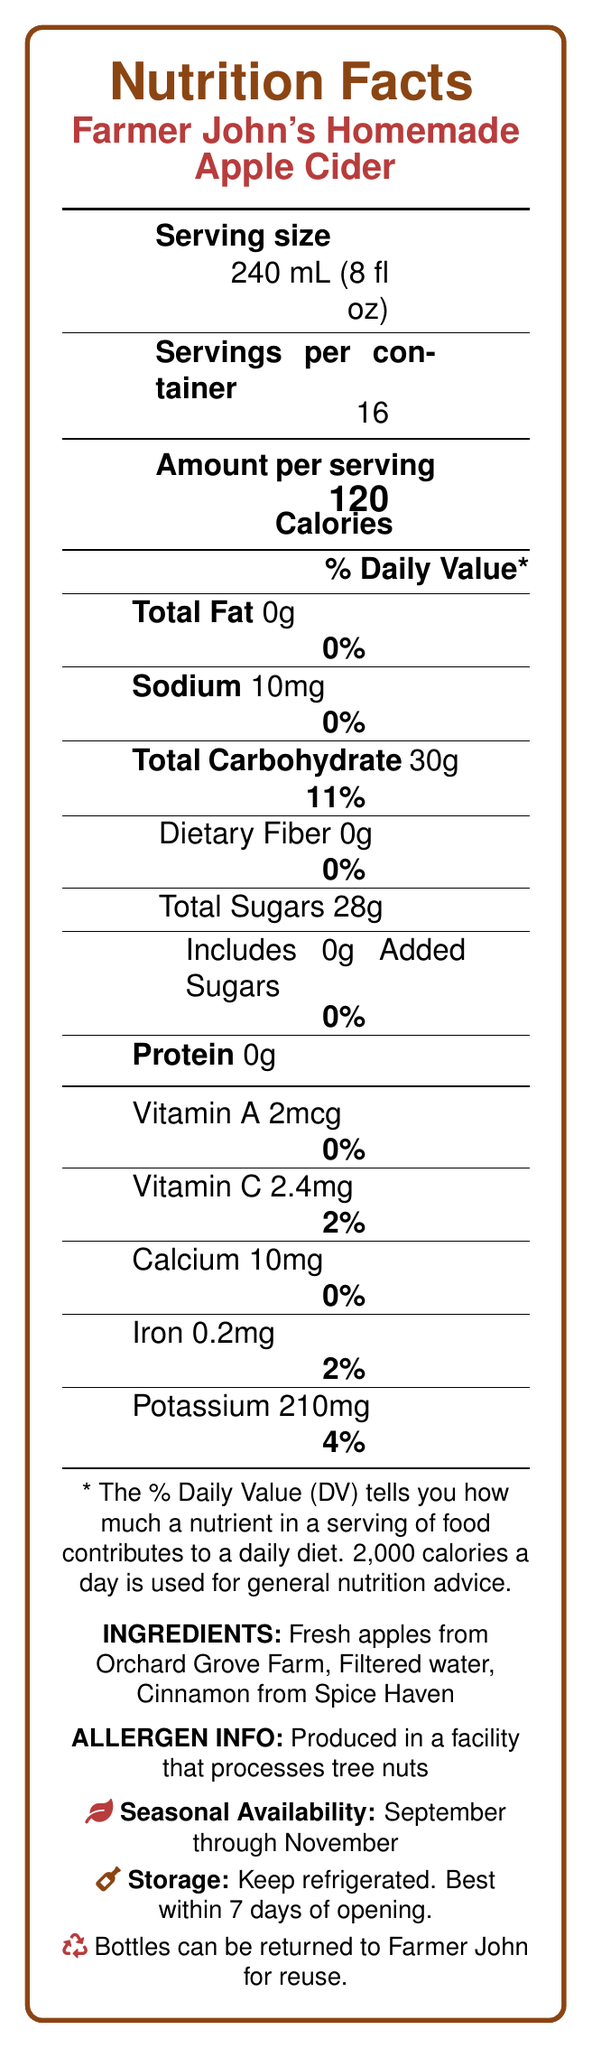What is the serving size for Farmer John's Homemade Apple Cider? The serving size is listed at the beginning of the document in the Nutrition Facts section.
Answer: 240 mL (8 fl oz) How many calories are in one serving of the apple cider? The document specifies that each serving contains 120 calories.
Answer: 120 calories How many grams of total sugars are in one serving? The total sugars per serving are specified as 28g in the Nutrition Facts section.
Answer: 28g Are there any added sugars in Farmer John’s Homemade Apple Cider? The document states that the apple cider includes 0g of added sugars.
Answer: No What is the ingredient list for Farmer John's Homemade Apple Cider? The ingredients are listed at the bottom of the Nutrition Facts.
Answer: Fresh apples from Orchard Grove Farm, Filtered water, Cinnamon from Spice Haven What are some of the serving suggestions provided for the apple cider? These suggestions are found in the "eventPlannerNotes" section.
Answer: Serve chilled in Mason jars, Garnish with a cinnamon stick, Offer as a welcome drink at autumn weddings What percentage of the daily value does the sodium content in one serving represent? The sodium content per serving is listed as 10mg, which is 0% of the daily value.
Answer: 0% Farmer John's Homemade Apple Cider is made from which apple varieties? A. Granny Smith, Golden Delicious, Fuji B. Honeycrisp, Gala, Fuji C. Red Delicious, Honeycrisp, Gala The document indicates that the apple cider is made from Honeycrisp, Gala, and Fuji apple varieties.
Answer: B What is the seasonal availability of Farmer John's Homemade Apple Cider? A. June through August B. September through November C. December through February D. March through May The cider is available from September through November, as stated in the seasonal availability section.
Answer: B Does the cider contain any dietary fiber? The document lists 0g of dietary fiber per serving.
Answer: No Can the bottles be returned for reuse? The document states that bottles can be returned to Farmer John for reuse.
Answer: Yes What facility process information is provided about the cider's production in terms of allergens? This detail is listed under "ALLERGEN INFO".
Answer: Produced in a facility that processes tree nuts How should the cider be stored after opening? The storage instructions specify to keep the cider refrigerated and consume it within seven days of opening.
Answer: Keep refrigerated. Best consumed within 7 days of opening. What is the main idea of the document? It covers various aspects, including nutritional facts, serving suggestions, ingredient sources, and sustainability information related to the homemade apple cider.
Answer: The document provides nutritional information, ingredient details, serving suggestions, and storage instructions for Farmer John’s Homemade Apple Cider. How much potassium does one serving of the apple cider contain, and what percent of the daily value does it represent? The document specifies that one serving contains 210mg of potassium, which is 4% of the daily value.
Answer: 210mg, 4% Describe some decoration tips for serving the apple cider at an event. These tips are found under "decorationTips" in the event planner notes.
Answer: Display in rustic wooden barrels, Use burlap ribbon to tie custom labels, Surround serving area with fall leaves and mini pumpkins Does the cider provide any vitamin C? The document lists the vitamin C content as 2.4mg, which is 2% of the daily value.
Answer: Yes, 2.4mg (2% daily value) How many servings are in one container of Farmer John’s Homemade Apple Cider? The document specifies that each container holds 16 servings.
Answer: 16 What protein content does one serving of the cider have? The protein content per serving is listed as 0g.
Answer: 0g Can the sustainability information of producing the apple cider be determined from the document? The sustainability information is stated in the document, mentioning that the cider is made with locally sourced apples and bottles can be returned for reuse.
Answer: Yes 